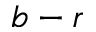<formula> <loc_0><loc_0><loc_500><loc_500>b - r</formula> 